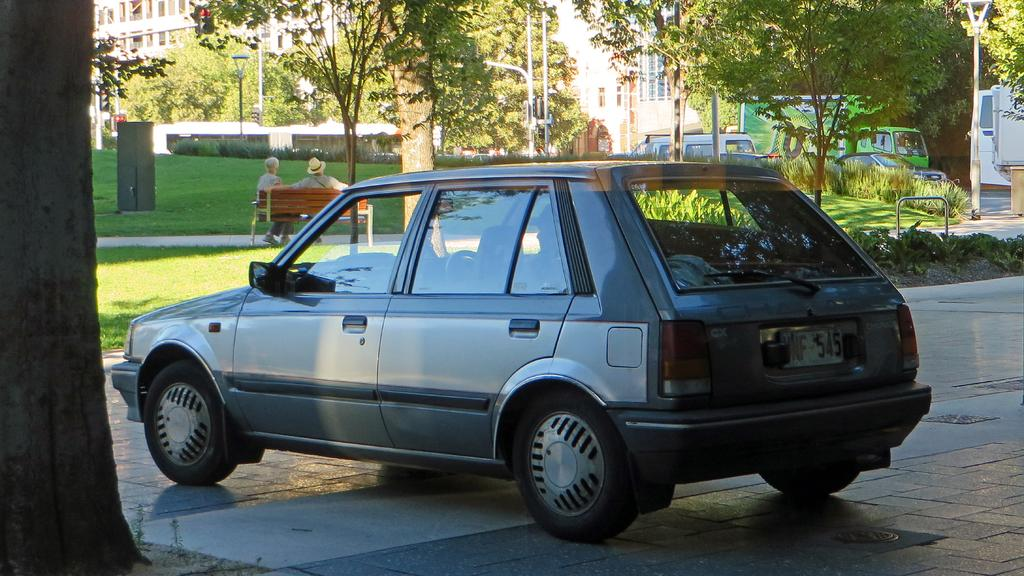What types of objects can be seen in the image? There are vehicles, grass, plants, buildings, trees, lights, and poles in the image. What can be found in the natural environment in the image? Grass, plants, and trees are present in the natural environment in the image. What are the people in the image doing? There are two persons sitting on a bench in the image. What type of structures are visible in the image? Buildings and poles are visible in the image. Where is the crate located in the image? There is no crate present in the image. What direction are the people pointing in the image? There are no people pointing in the image; the two persons are sitting on a bench. 